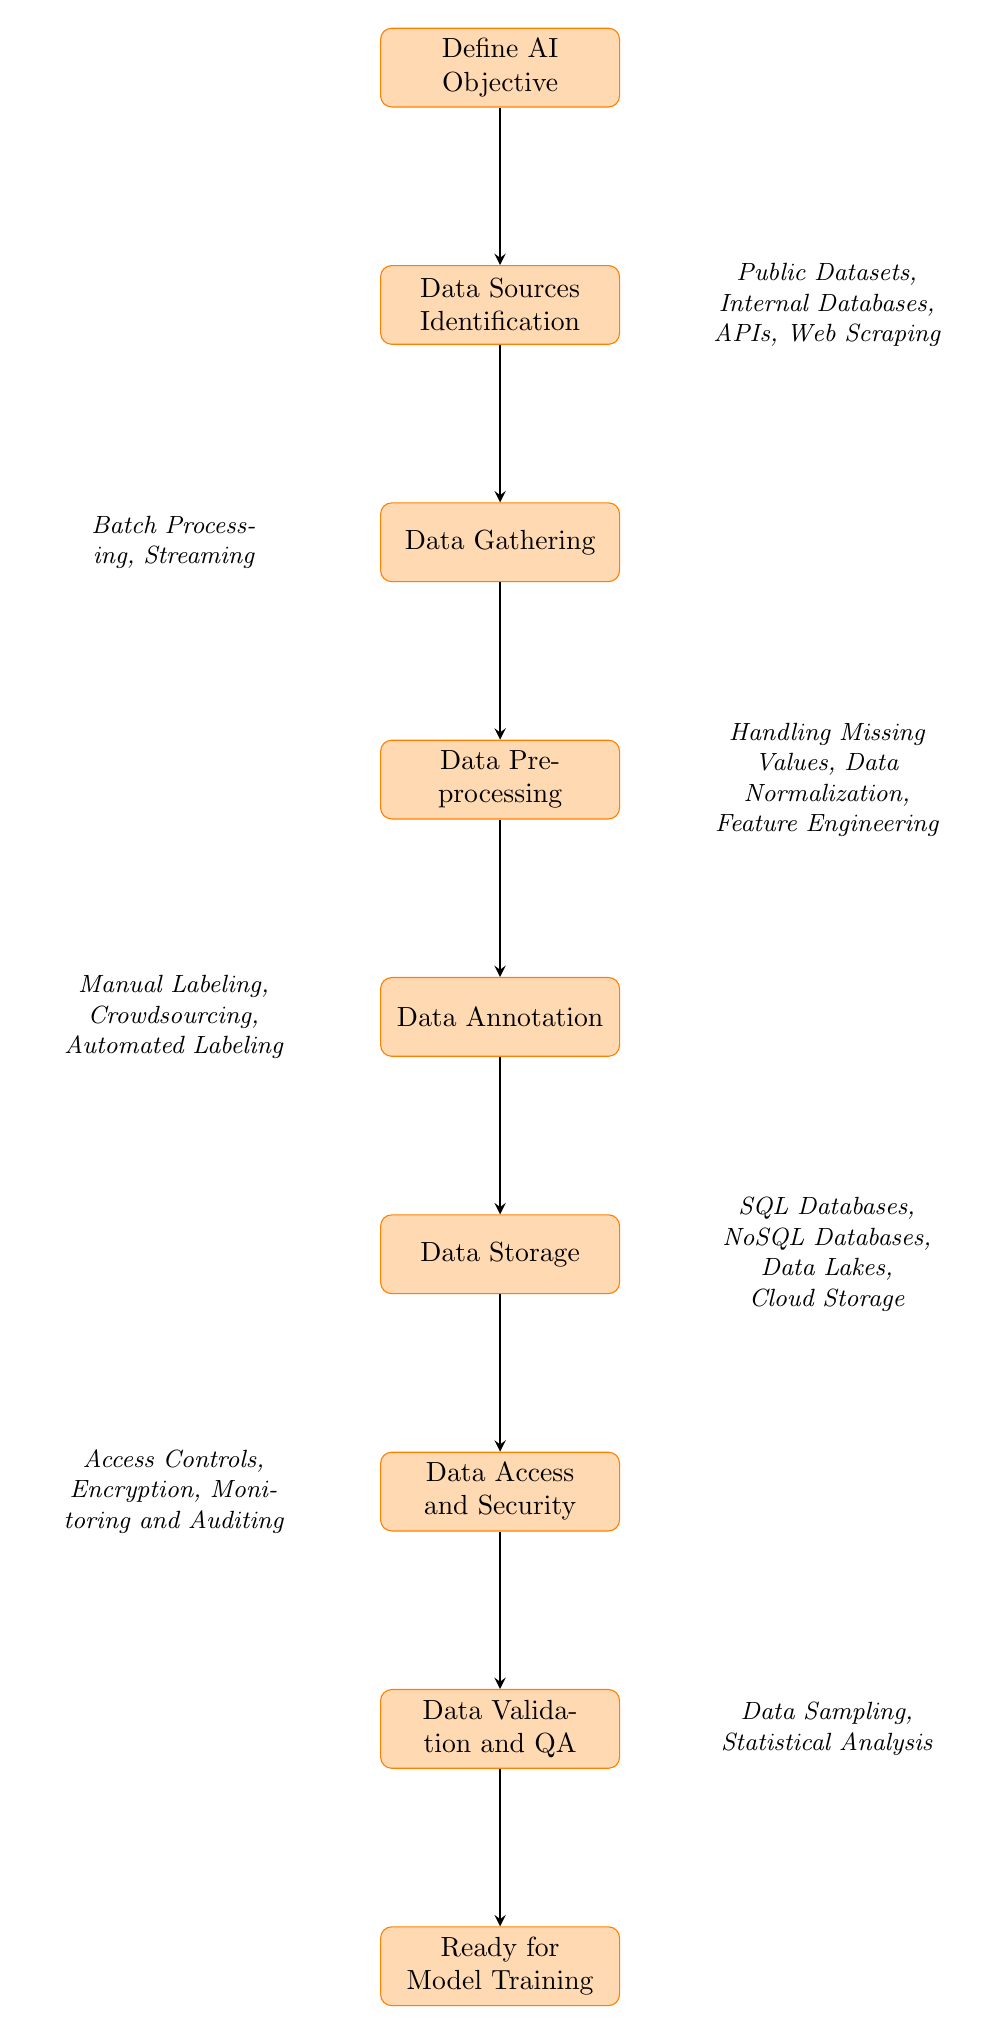What is the first step in the data collection process? The first step indicated in the diagram is "Define AI Objective". This node is at the top of the flow chart, which signifies it as the starting point of the process.
Answer: Define AI Objective How many nodes are in the diagram? By counting the distinct steps in the flow chart, there are a total of eight nodes present, which include all main processes from start to end.
Answer: Eight Which node comes after Data Gathering? The node that follows "Data Gathering" in the flowchart is "Data Preprocessing". The arrows in the diagram show the directional flow leading from one node to the next.
Answer: Data Preprocessing What methods are used for Data Gathering? The diagram lists "Batch Processing" and "Streaming" under the Data Gathering node, indicating that these are the two methods available for collecting data.
Answer: Batch Processing, Streaming What types of data storage options are mentioned? The storage options noted in the diagram are "SQL Databases", "NoSQL Databases", "Data Lakes", and "Cloud Storage", specified in the Data Storage node as suitable solutions.
Answer: SQL Databases, NoSQL Databases, Data Lakes, Cloud Storage Which step includes ensuring secure access to data? The flow chart indicates that "Data Access and Security" is the step that specifically addresses the measures for ensuring secure access to the data. This is positioned below the Data Storage node.
Answer: Data Access and Security What processes are involved in Data Validation and QA? "Data Validation and QA" includes "Data Sampling" and "Statistical Analysis" as processes to validate the quality and accuracy of the data, as shown in the corresponding node of the diagram.
Answer: Data Sampling, Statistical Analysis What is the final output of this process? The last node in the flow chart is "Ready for Model Training," signifying that after completing all prior steps, the data is prepared for training AI models.
Answer: Ready for Model Training 